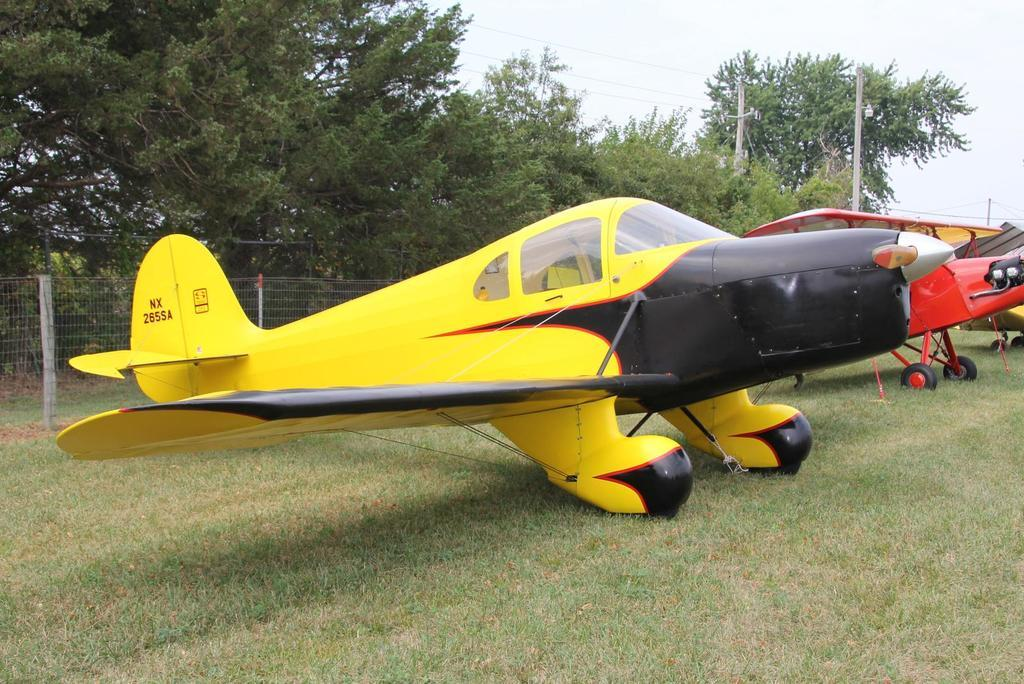What is the main subject of the image? The main subject of the image is airplanes on the ground. What can be seen in the background of the image? In the background of the image, there are trees, grass, current poles, a fence, and the sky. How many airplanes are visible in the image? The number of airplanes is not specified, but there are airplanes on the ground in the image. What type of animals can be seen in the zoo in the image? There is no zoo present in the image; it features airplanes on the ground and various background elements. 